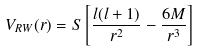Convert formula to latex. <formula><loc_0><loc_0><loc_500><loc_500>V _ { R W } ( r ) = S \left [ \frac { l ( l + 1 ) } { r ^ { 2 } } - \frac { 6 M } { r ^ { 3 } } \right ]</formula> 